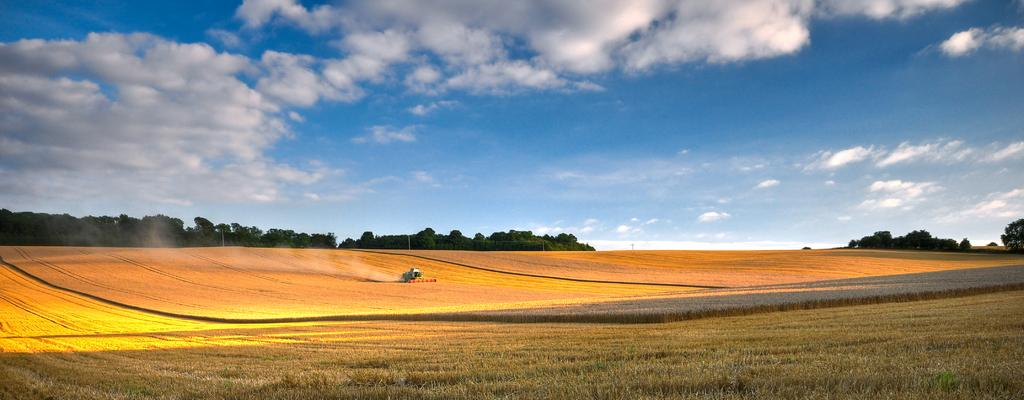What type of vegetation is present on the ground in the image? There is grass on the ground in the front of the image. What can be seen in the background of the image? There are trees in the background of the image. How would you describe the sky in the image? The sky is cloudy in the image. Where is the zoo located in the image? There is no zoo present in the image. What type of milk is being served in the image? There is no milk present in the image. 